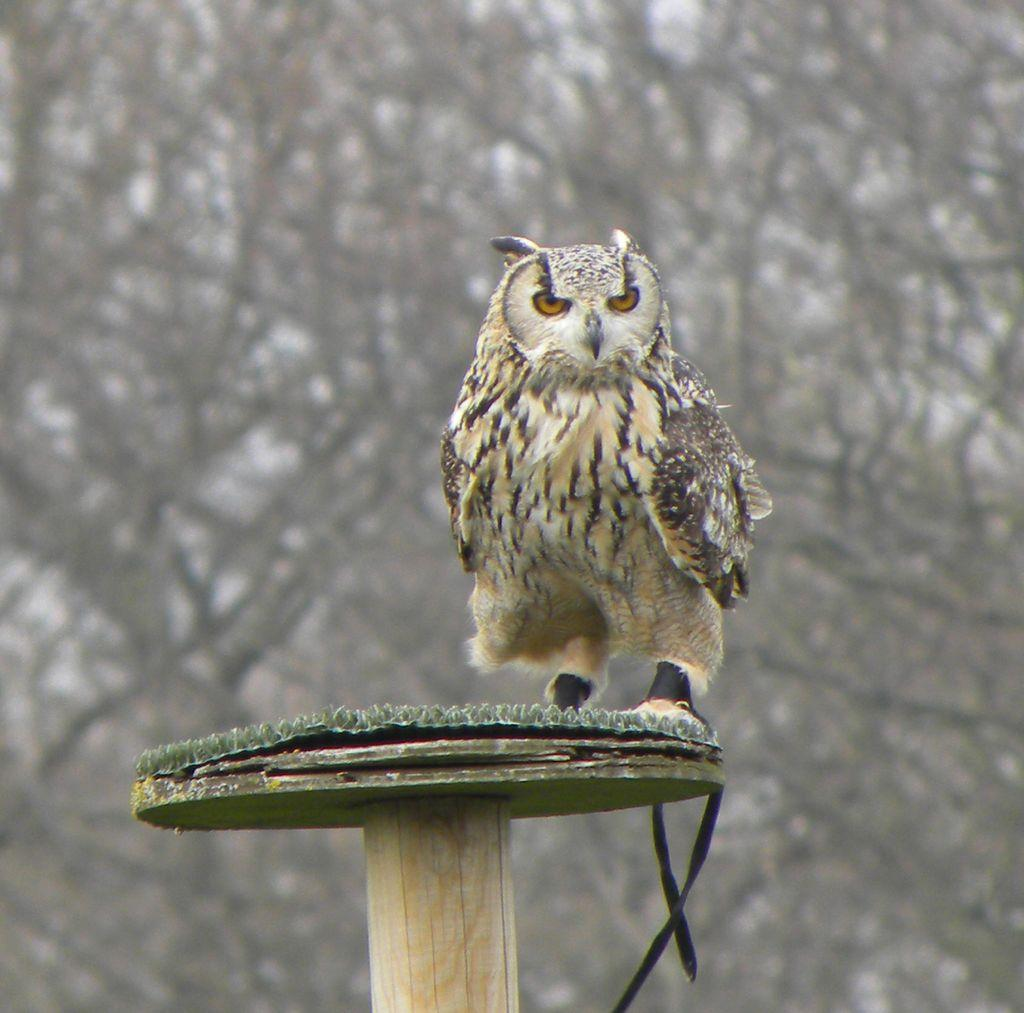What is the main subject of the image? There is an owl in the center of the image. Where is the owl located? The owl is on a wooden pole. What can be seen in the background of the image? There are trees in the background of the image. What type of print can be seen on the owl's feet in the image? There is no print visible on the owl's feet in the image, as the owl's feet are not shown in detail. How many cherries are hanging from the branches of the trees in the background? There are no cherries visible in the image; only trees are present in the background. 